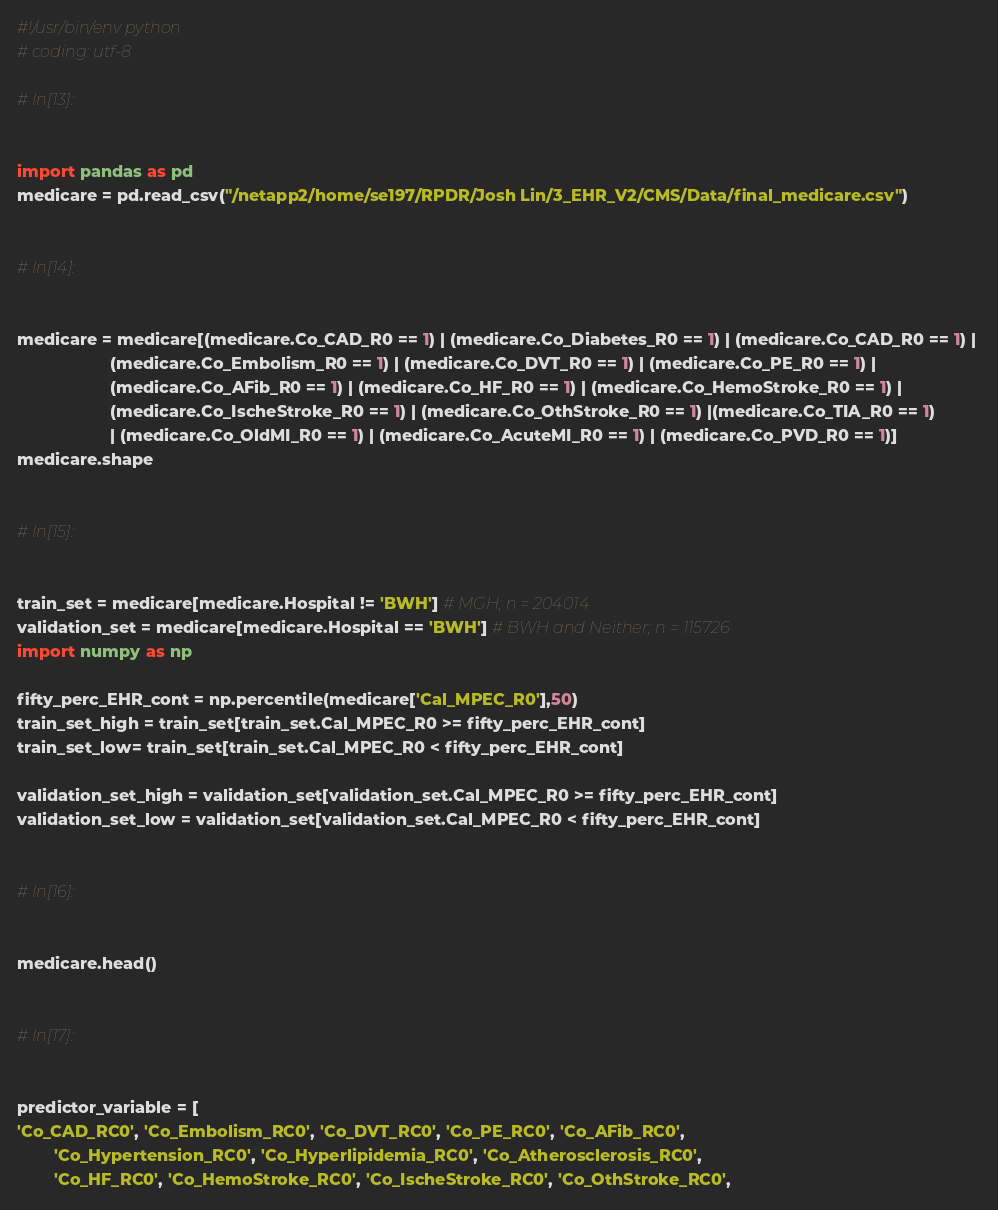Convert code to text. <code><loc_0><loc_0><loc_500><loc_500><_Python_>#!/usr/bin/env python
# coding: utf-8

# In[13]:


import pandas as pd
medicare = pd.read_csv("/netapp2/home/se197/RPDR/Josh Lin/3_EHR_V2/CMS/Data/final_medicare.csv")


# In[14]:


medicare = medicare[(medicare.Co_CAD_R0 == 1) | (medicare.Co_Diabetes_R0 == 1) | (medicare.Co_CAD_R0 == 1) | 
                    (medicare.Co_Embolism_R0 == 1) | (medicare.Co_DVT_R0 == 1) | (medicare.Co_PE_R0 == 1) | 
                    (medicare.Co_AFib_R0 == 1) | (medicare.Co_HF_R0 == 1) | (medicare.Co_HemoStroke_R0 == 1) | 
                    (medicare.Co_IscheStroke_R0 == 1) | (medicare.Co_OthStroke_R0 == 1) |(medicare.Co_TIA_R0 == 1)
                    | (medicare.Co_OldMI_R0 == 1) | (medicare.Co_AcuteMI_R0 == 1) | (medicare.Co_PVD_R0 == 1)]
medicare.shape


# In[15]:


train_set = medicare[medicare.Hospital != 'BWH'] # MGH; n = 204014
validation_set = medicare[medicare.Hospital == 'BWH'] # BWH and Neither; n = 115726
import numpy as np

fifty_perc_EHR_cont = np.percentile(medicare['Cal_MPEC_R0'],50)
train_set_high = train_set[train_set.Cal_MPEC_R0 >= fifty_perc_EHR_cont]
train_set_low= train_set[train_set.Cal_MPEC_R0 < fifty_perc_EHR_cont]

validation_set_high = validation_set[validation_set.Cal_MPEC_R0 >= fifty_perc_EHR_cont]
validation_set_low = validation_set[validation_set.Cal_MPEC_R0 < fifty_perc_EHR_cont]


# In[16]:


medicare.head()


# In[17]:


predictor_variable = [
'Co_CAD_RC0', 'Co_Embolism_RC0', 'Co_DVT_RC0', 'Co_PE_RC0', 'Co_AFib_RC0',
        'Co_Hypertension_RC0', 'Co_Hyperlipidemia_RC0', 'Co_Atherosclerosis_RC0',
        'Co_HF_RC0', 'Co_HemoStroke_RC0', 'Co_IscheStroke_RC0', 'Co_OthStroke_RC0',</code> 